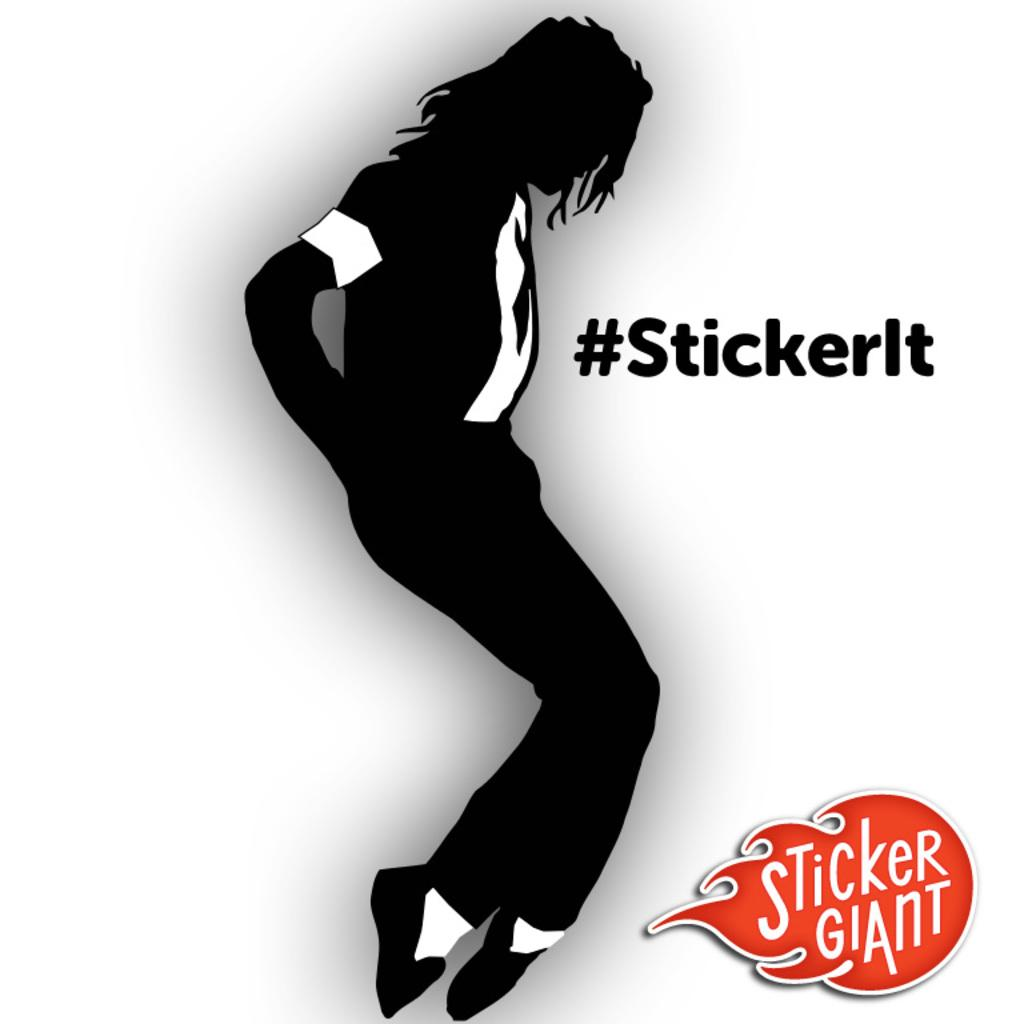What can be observed about the image that indicates it has been edited? The image has been edited, as evidenced by the presence of texts written on it. Can you describe the nature of the texts on the image? The texts on the image are written in a specific font and color, and they may contain words, phrases, or sentences. What type of heat can be felt coming from the chain in the image? There is no chain present in the image, so it is not possible to determine if any heat is associated with it. 